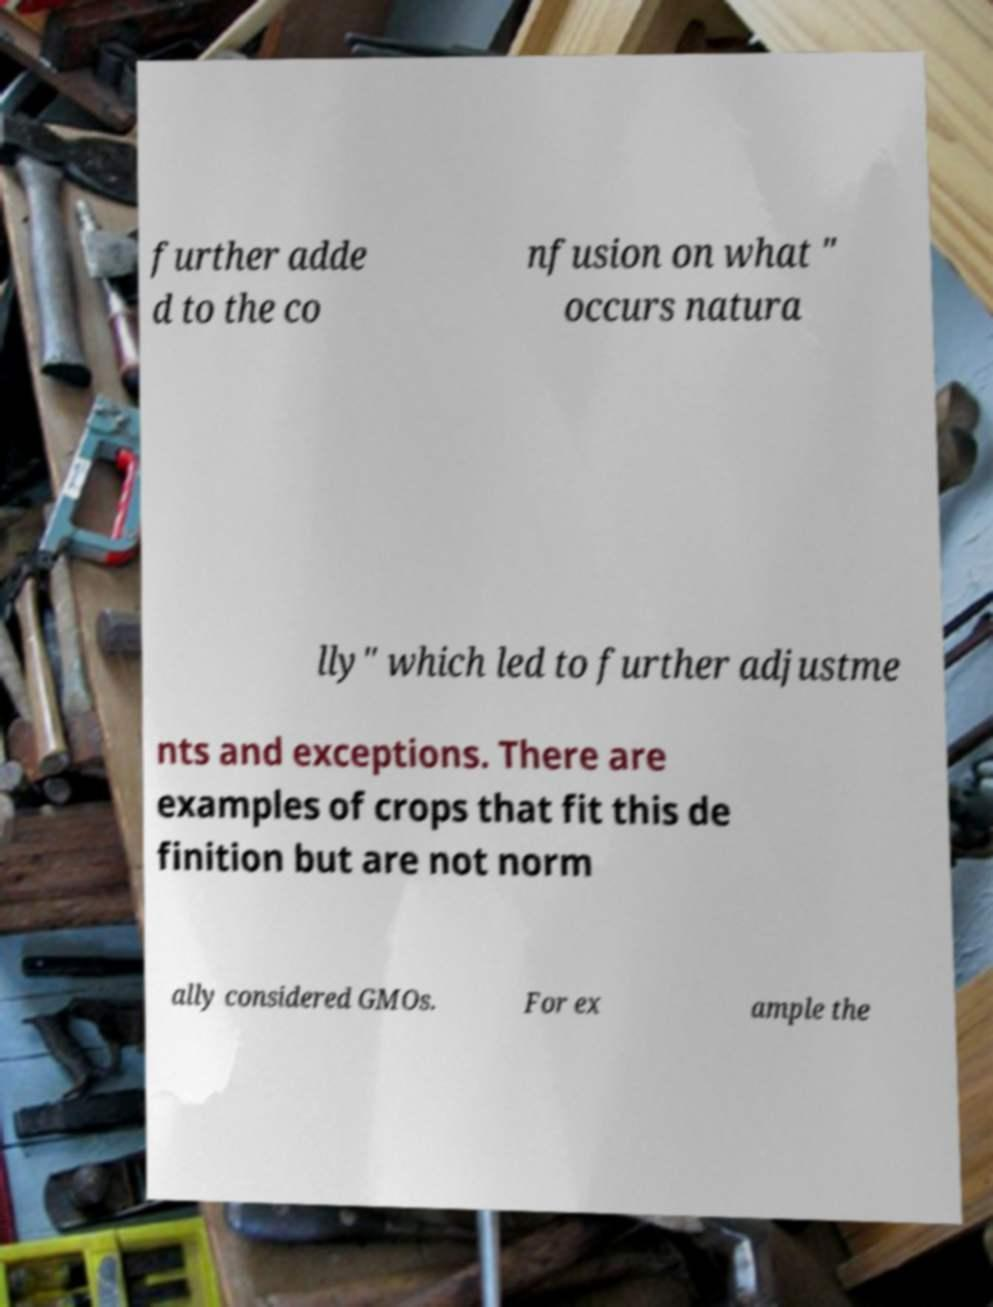For documentation purposes, I need the text within this image transcribed. Could you provide that? further adde d to the co nfusion on what " occurs natura lly" which led to further adjustme nts and exceptions. There are examples of crops that fit this de finition but are not norm ally considered GMOs. For ex ample the 